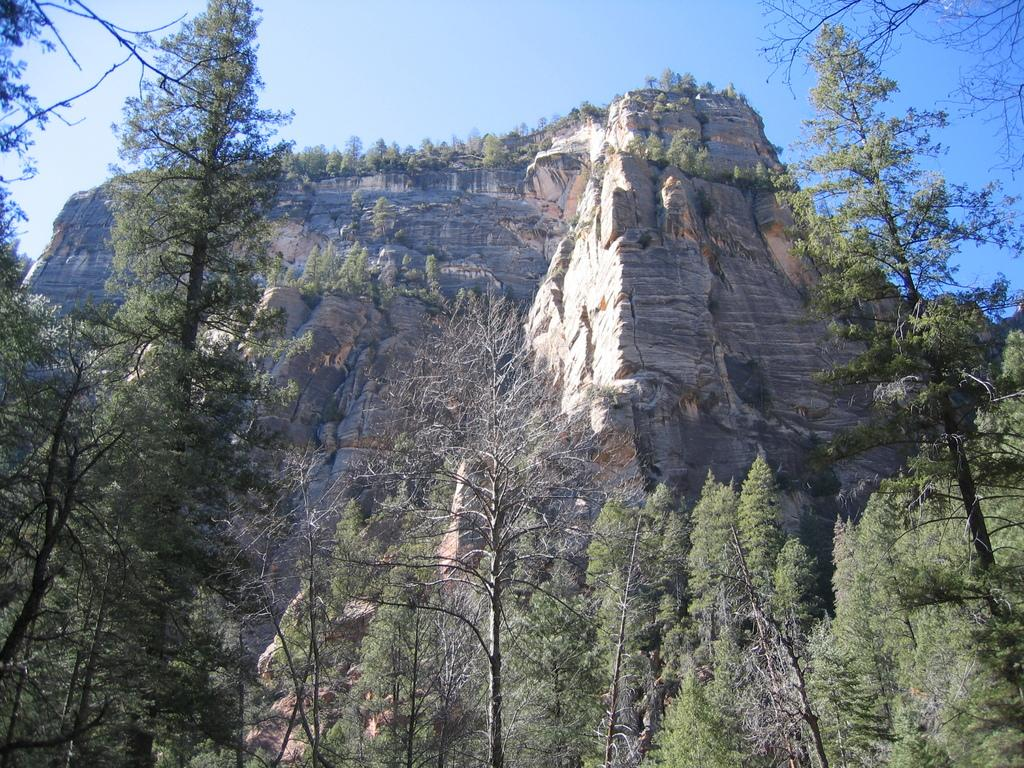What type of natural features can be seen in the image? There are trees and mountains in the image. What is visible in the background of the image? The sky is visible in the background of the image. What type of pail is being used by the maid in the image? There is no pail or maid present in the image. What is the air quality like in the image? The provided facts do not give any information about the air quality in the image. 